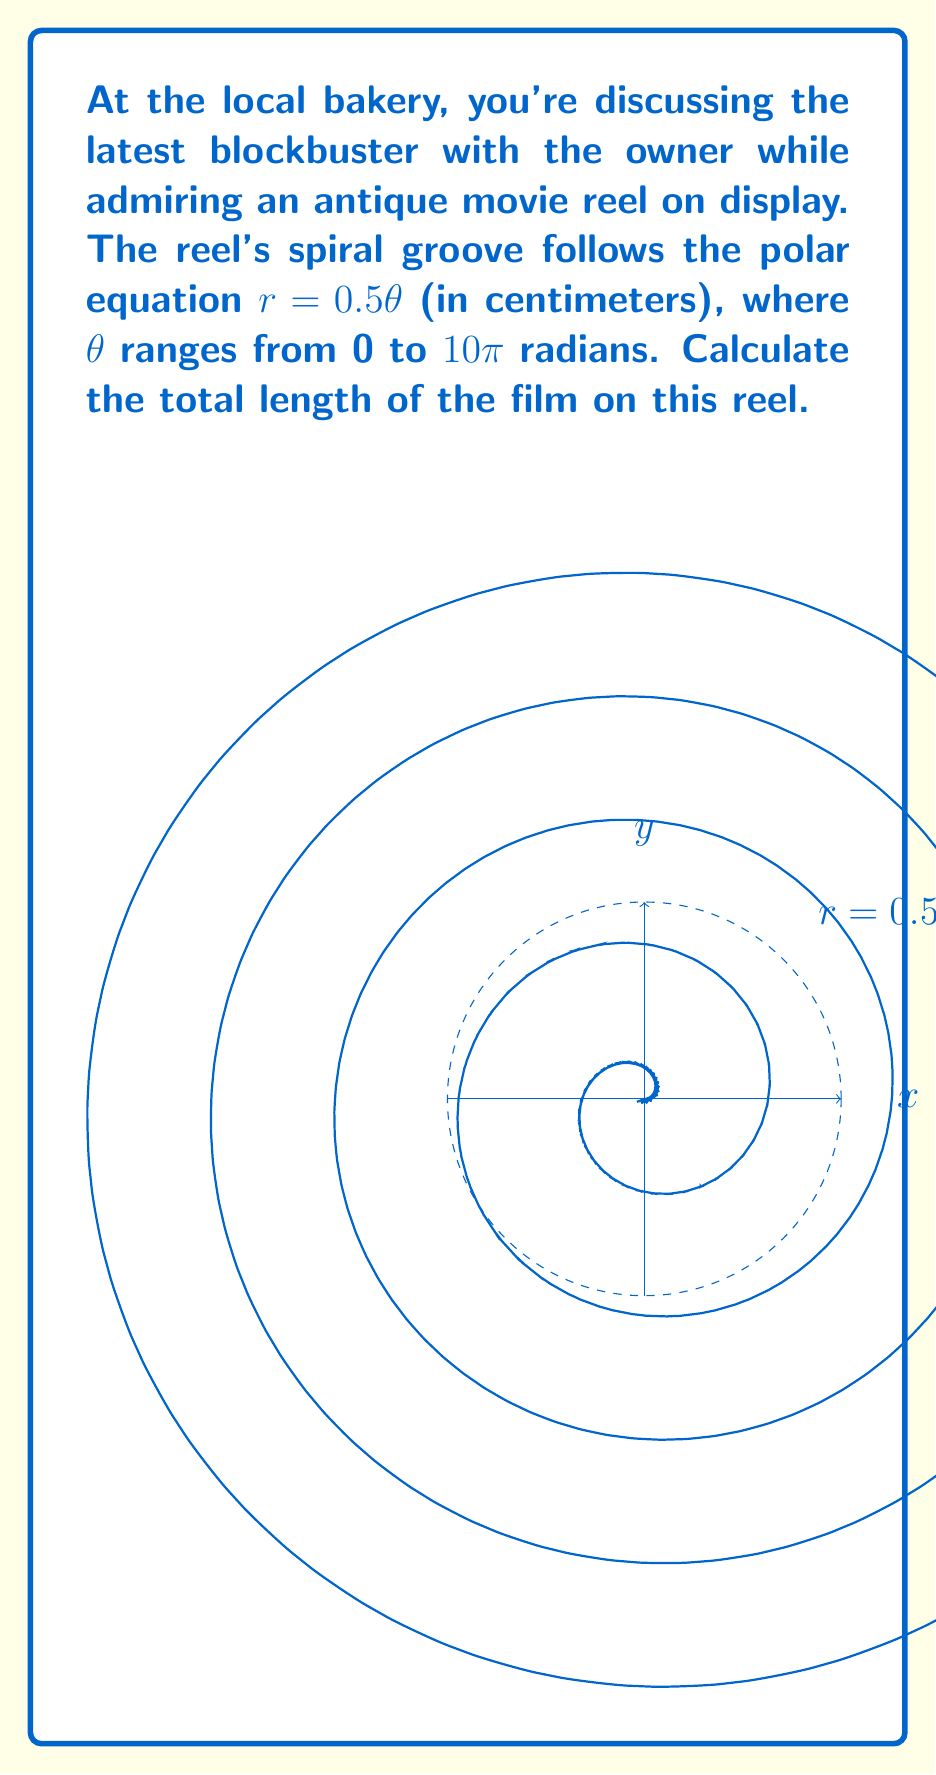Teach me how to tackle this problem. To calculate the arc length in polar coordinates, we use the formula:

$$L = \int_a^b \sqrt{r^2 + \left(\frac{dr}{d\theta}\right)^2} d\theta$$

Given: $r = 0.5\theta$, $\theta$ ranges from 0 to $10\pi$

Step 1: Find $\frac{dr}{d\theta}$
$$\frac{dr}{d\theta} = 0.5$$

Step 2: Substitute into the arc length formula
$$L = \int_0^{10\pi} \sqrt{(0.5\theta)^2 + (0.5)^2} d\theta$$

Step 3: Simplify under the square root
$$L = \int_0^{10\pi} \sqrt{0.25\theta^2 + 0.25} d\theta$$
$$L = 0.5 \int_0^{10\pi} \sqrt{\theta^2 + 1} d\theta$$

Step 4: This integral can be solved using the substitution $\theta = \sinh u$
$$L = 0.5 \int_0^{\sinh^{-1}(10\pi)} \sqrt{\sinh^2 u + 1} \cosh u du$$
$$L = 0.5 \int_0^{\sinh^{-1}(10\pi)} \cosh^2 u du$$

Step 5: Use the identity $\cosh^2 u = \frac{1}{2}(\cosh 2u + 1)$
$$L = 0.25 \int_0^{\sinh^{-1}(10\pi)} (\cosh 2u + 1) du$$
$$L = 0.25 \left[\frac{1}{2}\sinh 2u + u\right]_0^{\sinh^{-1}(10\pi)}$$

Step 6: Evaluate the integral
$$L = 0.25 \left[\frac{1}{2}\sinh(2\sinh^{-1}(10\pi)) + \sinh^{-1}(10\pi)\right]$$

Step 7: Simplify using hyperbolic function identities
$$L = 0.25 \left[5\pi\sqrt{100\pi^2 + 1} + \sinh^{-1}(10\pi)\right]$$

The final result is in centimeters.
Answer: $0.25 [5\pi\sqrt{100\pi^2 + 1} + \sinh^{-1}(10\pi)]$ cm 